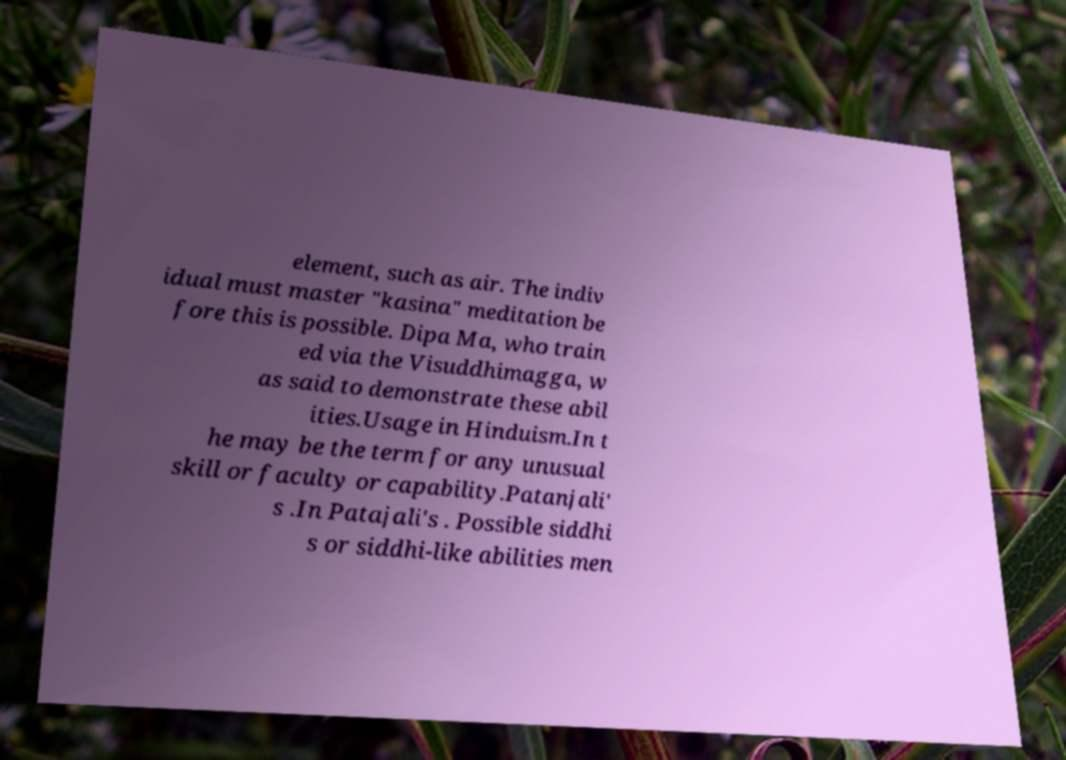Could you extract and type out the text from this image? element, such as air. The indiv idual must master "kasina" meditation be fore this is possible. Dipa Ma, who train ed via the Visuddhimagga, w as said to demonstrate these abil ities.Usage in Hinduism.In t he may be the term for any unusual skill or faculty or capability.Patanjali' s .In Patajali's . Possible siddhi s or siddhi-like abilities men 